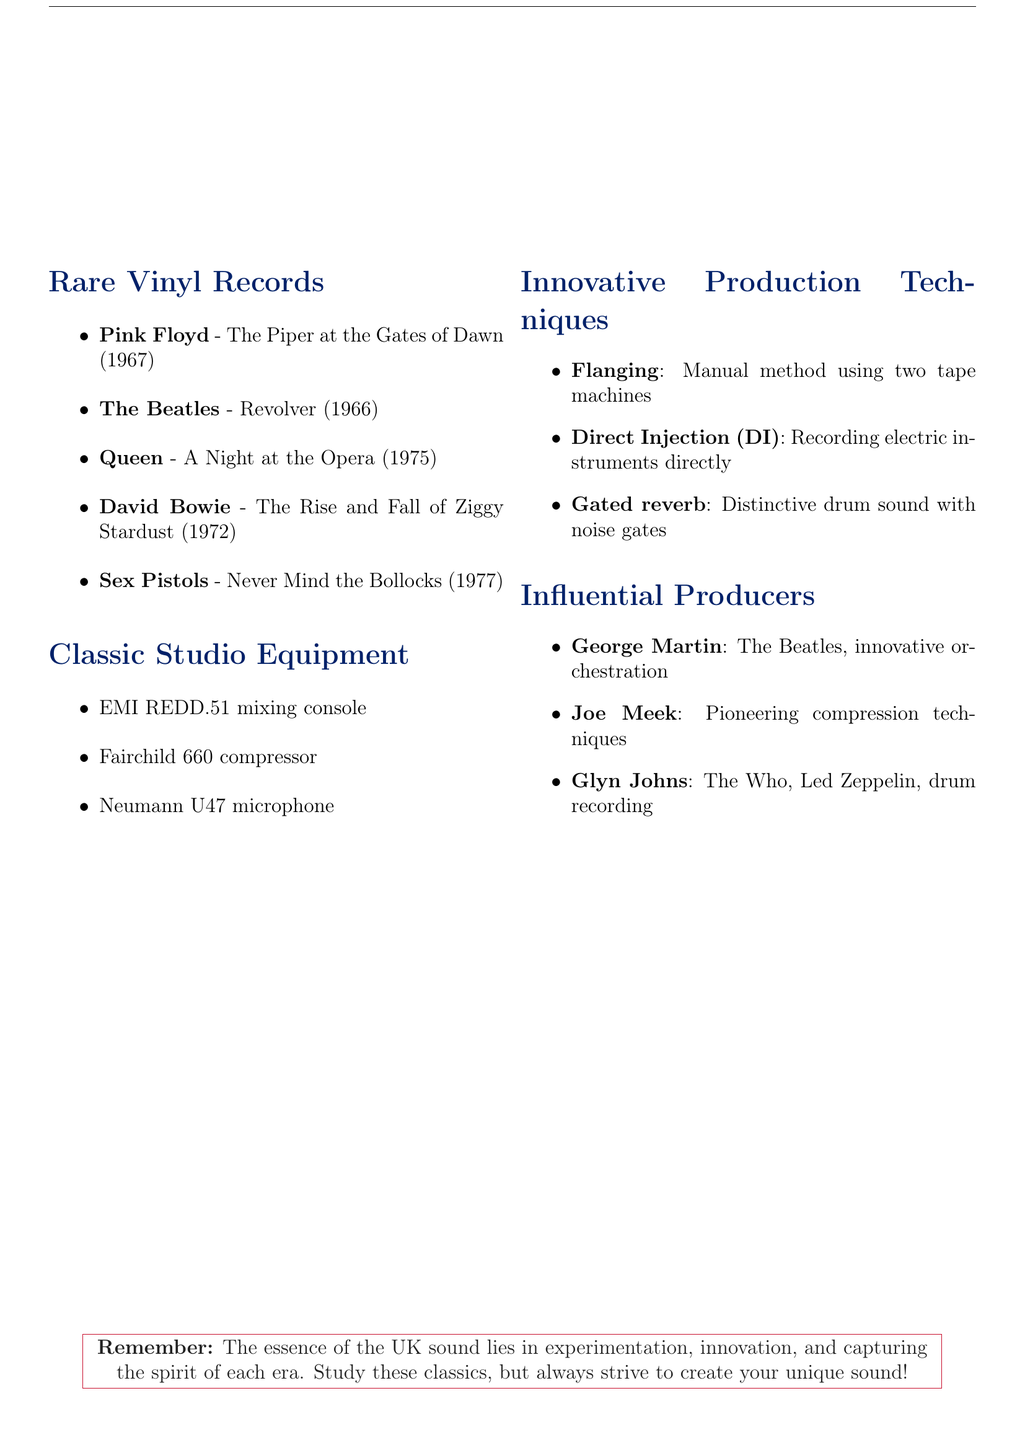What year was "The Piper at the Gates of Dawn" released? The release year of "The Piper at the Gates of Dawn" is mentioned in the document, which is 1967.
Answer: 1967 What is the estimated value range of "Revolver"? The document states the estimated value for "Revolver" is between £800 and £1,200.
Answer: £800 - £1,200 Which producer is known for innovative orchestration? The document lists George Martin as known for innovative orchestration associated with The Beatles.
Answer: George Martin What production technique involves recording electric instruments directly? The technique described in the document is called Direct Injection (DI).
Answer: Direct Injection (DI) What label released "Never Mind the Bollocks, Here's the Sex Pistols"? The document specifies that "Never Mind the Bollocks" was released by Virgin.
Answer: Virgin Which year did David Bowie's "The Rise and Fall of Ziggy Stardust" come out? The release year of David Bowie's album is provided as 1972 in the document.
Answer: 1972 What mixing console is used at Abbey Road Studios? The document indicates the use of the EMI REDD.51 mixing console at Abbey Road Studios.
Answer: EMI REDD.51 mixing console What technique was popularized by UK engineers involving two tape machines? The technique mentioned in the document is Flanging, which was created manually using two tape machines.
Answer: Flanging What is the rarity of "A Night at the Opera"? The document states that "A Night at the Opera" is a first UK pressing with an EMI stamp.
Answer: First UK pressing with EMI stamp 